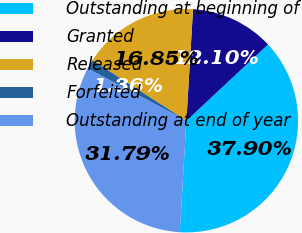Convert chart. <chart><loc_0><loc_0><loc_500><loc_500><pie_chart><fcel>Outstanding at beginning of<fcel>Granted<fcel>Released<fcel>Forfeited<fcel>Outstanding at end of year<nl><fcel>37.9%<fcel>12.1%<fcel>16.85%<fcel>1.36%<fcel>31.79%<nl></chart> 